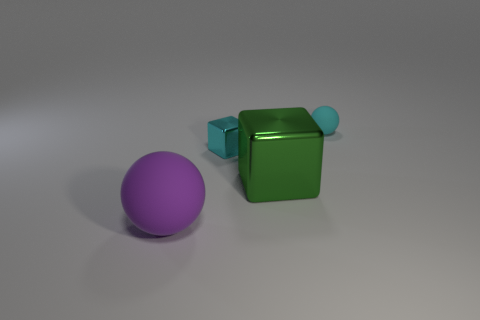What is the material of the tiny object on the left side of the rubber sphere that is behind the purple thing?
Your answer should be compact. Metal. Are there any green things that have the same material as the small sphere?
Your answer should be very brief. No. There is a sphere that is the same size as the cyan metal object; what is its material?
Your answer should be very brief. Rubber. What is the size of the matte ball that is to the left of the rubber object that is behind the metal cube that is behind the green shiny block?
Offer a very short reply. Large. There is a big object on the right side of the small cyan shiny cube; is there a tiny cyan thing left of it?
Provide a succinct answer. Yes. There is a large purple object; does it have the same shape as the tiny object that is in front of the small matte thing?
Provide a short and direct response. No. What color is the matte sphere that is to the left of the small cyan matte object?
Make the answer very short. Purple. What size is the sphere that is left of the cyan thing that is in front of the tiny cyan sphere?
Provide a short and direct response. Large. Is the shape of the small cyan object in front of the small rubber thing the same as  the purple thing?
Ensure brevity in your answer.  No. What is the material of the small cyan thing that is the same shape as the big matte object?
Make the answer very short. Rubber. 